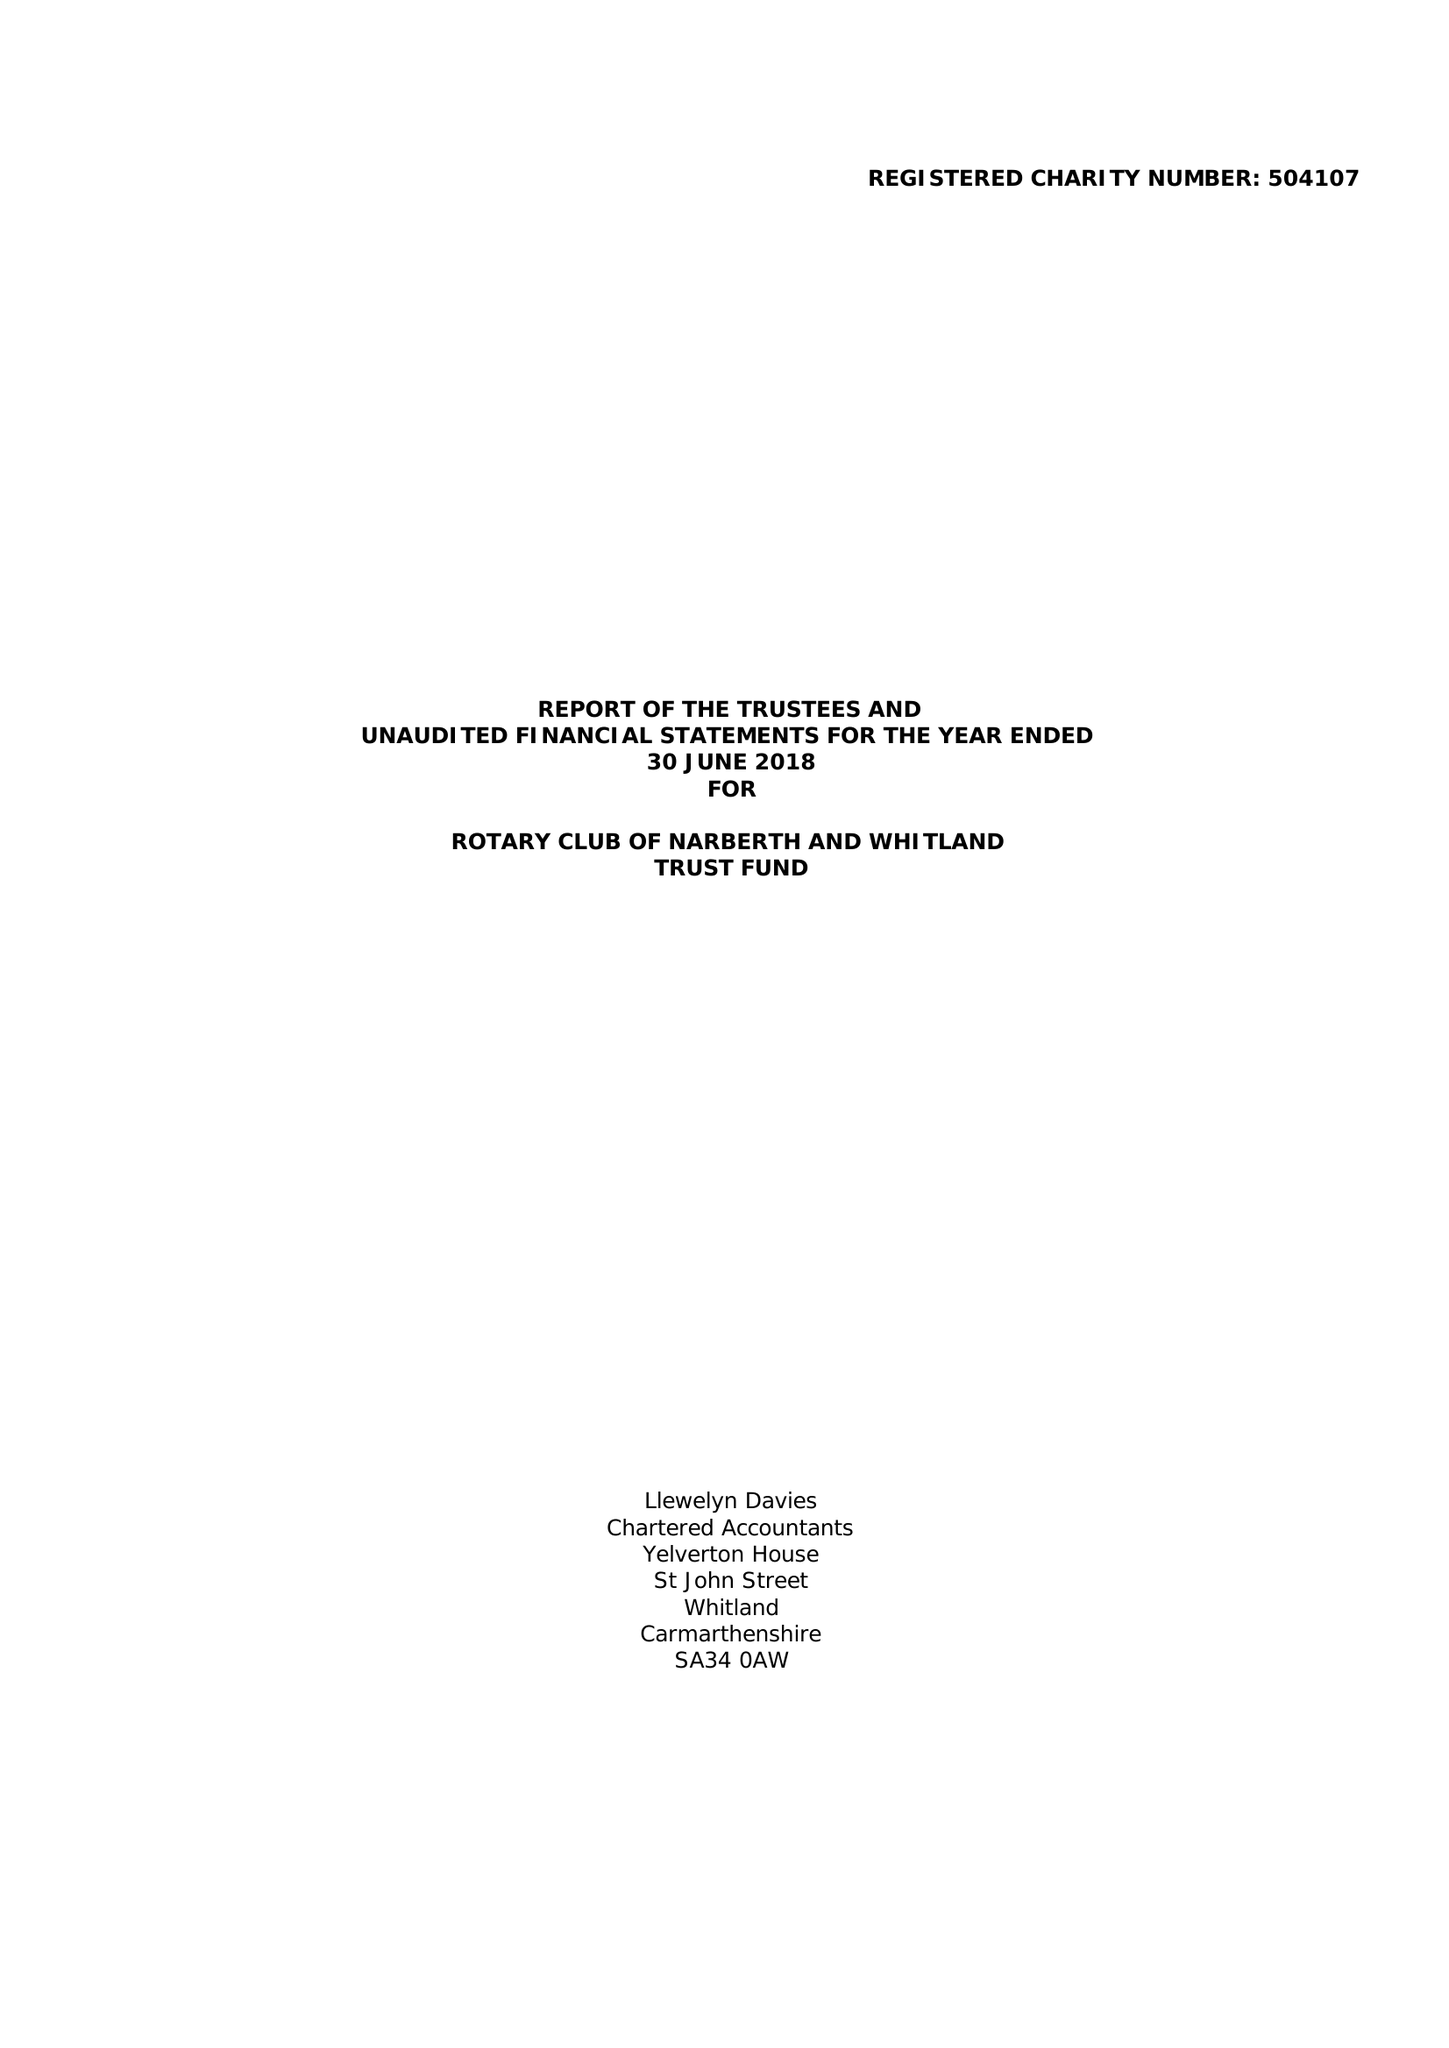What is the value for the address__post_town?
Answer the question using a single word or phrase. NARBERTH 